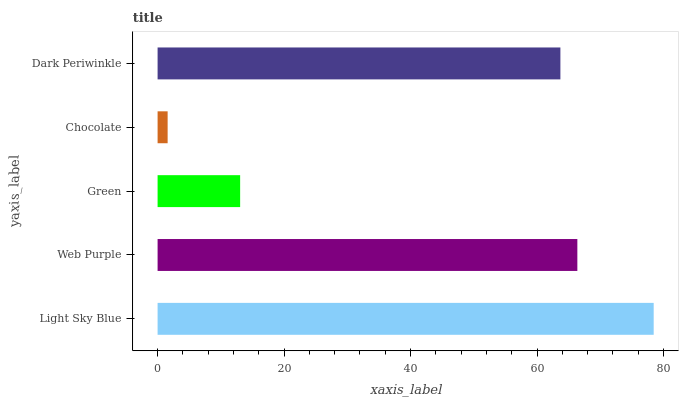Is Chocolate the minimum?
Answer yes or no. Yes. Is Light Sky Blue the maximum?
Answer yes or no. Yes. Is Web Purple the minimum?
Answer yes or no. No. Is Web Purple the maximum?
Answer yes or no. No. Is Light Sky Blue greater than Web Purple?
Answer yes or no. Yes. Is Web Purple less than Light Sky Blue?
Answer yes or no. Yes. Is Web Purple greater than Light Sky Blue?
Answer yes or no. No. Is Light Sky Blue less than Web Purple?
Answer yes or no. No. Is Dark Periwinkle the high median?
Answer yes or no. Yes. Is Dark Periwinkle the low median?
Answer yes or no. Yes. Is Chocolate the high median?
Answer yes or no. No. Is Green the low median?
Answer yes or no. No. 